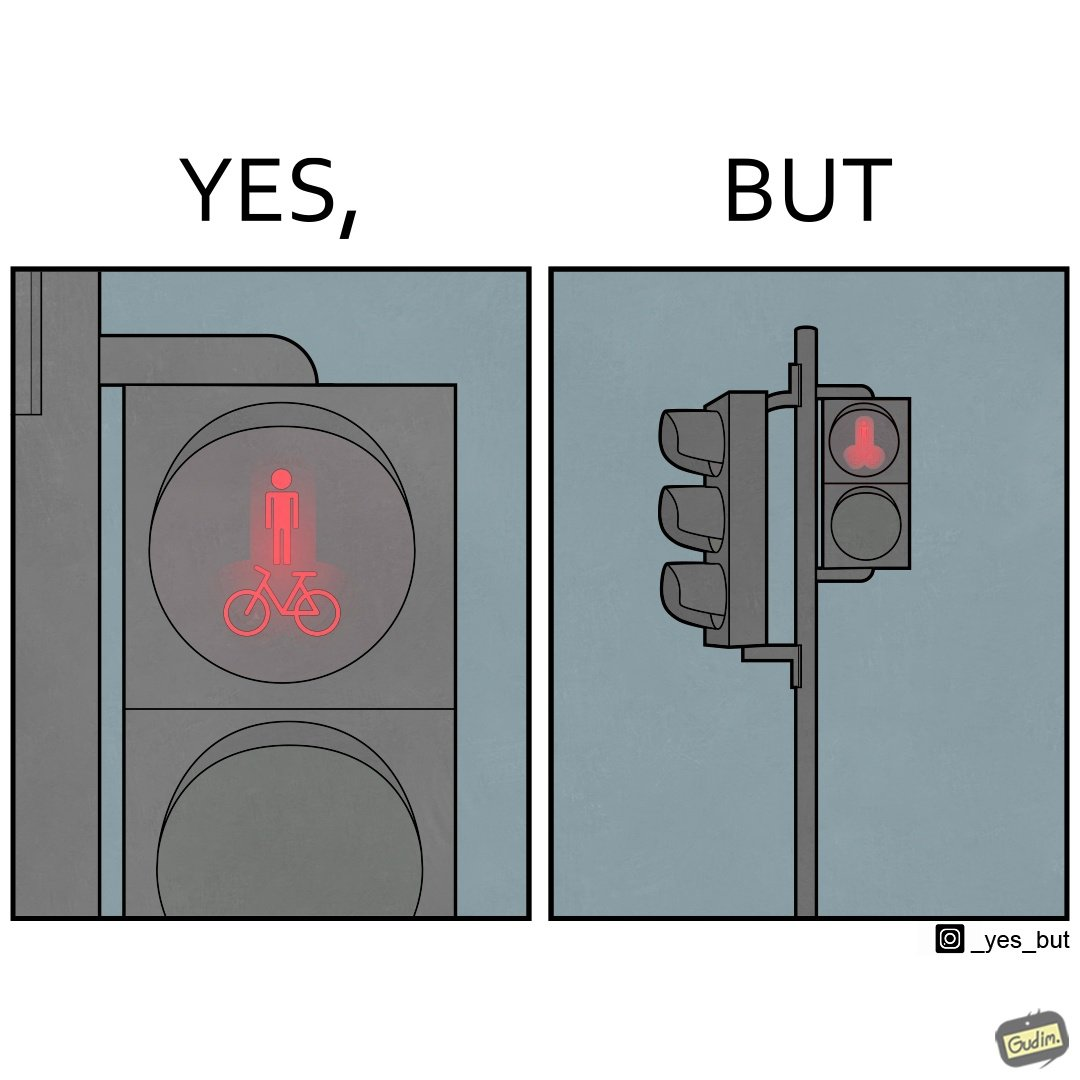Describe the contrast between the left and right parts of this image. In the left part of the image: A close up image of a traffic light meant for pedestrians and bicycles. The light has a stick figure of a human placed vertically above a drawing of a bicycle. Both are lit up in red, and inside the same circle. In the right part of the image: A traffic light pole with 2 lights.  Currently  the top red light is lit up. The light is a pedestrian light, but the symbol on it looks phallic, 2  circles and a cylinder between them. It is presumably not meant to look phallic but the  distance blurs the actual figures on the light. 